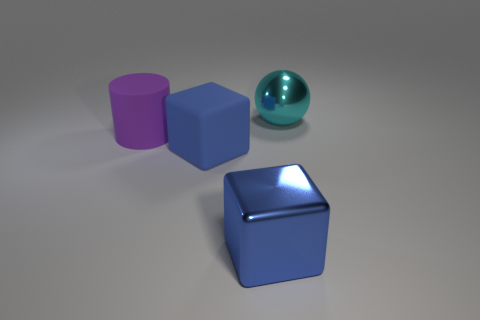Are there any other things that have the same shape as the cyan shiny object?
Your answer should be very brief. No. Are there an equal number of big blue objects left of the large cyan sphere and big things in front of the large purple rubber cylinder?
Provide a short and direct response. Yes. How many cylinders are big things or tiny blue things?
Make the answer very short. 1. How many other objects are the same material as the big ball?
Your answer should be very brief. 1. There is a big matte object that is to the left of the big blue matte block; what is its shape?
Your answer should be compact. Cylinder. What is the material of the object on the left side of the rubber object that is right of the large purple cylinder?
Your response must be concise. Rubber. Is the number of large metallic things that are behind the shiny cube greater than the number of big green cylinders?
Keep it short and to the point. Yes. How many other objects are the same color as the shiny ball?
Your response must be concise. 0. What is the shape of the rubber thing that is the same size as the matte cube?
Provide a short and direct response. Cylinder. How many blue matte cubes are behind the big shiny thing behind the object on the left side of the blue rubber cube?
Keep it short and to the point. 0. 